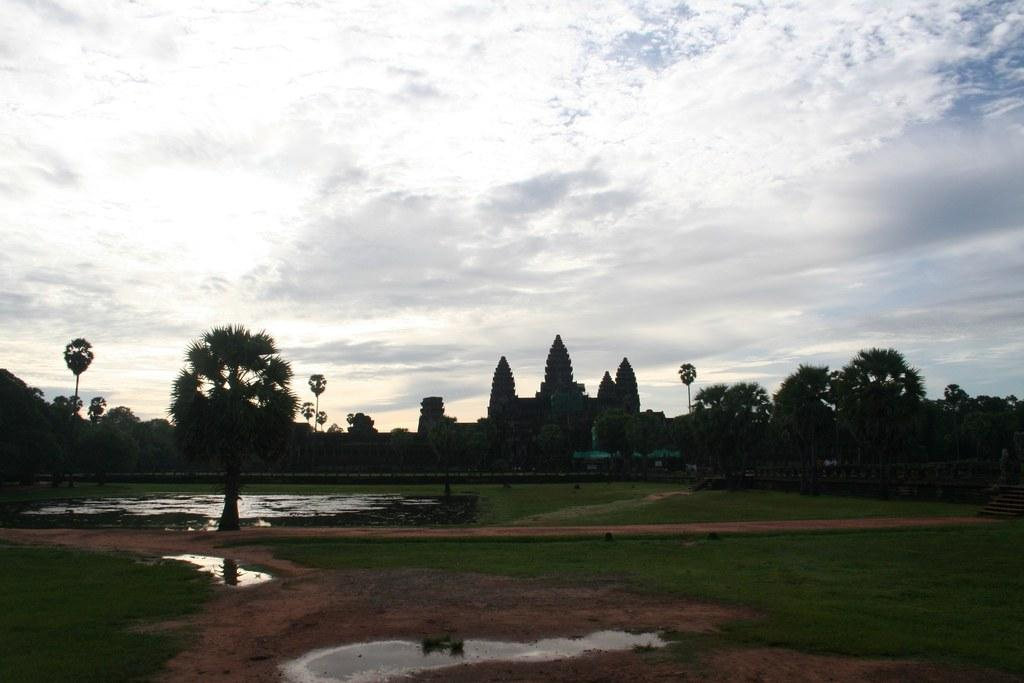What type of scenery is depicted in the image? There is a beautiful scenery in the image. What can be seen growing in the image? Crops are present in the image. What type of vegetation is visible in the image? There are plenty of trees in the image. What is visible in the background of the image? The sky is visible in the background of the image. Can you see a monkey exchanging a camera with a farmer in the image? There is no monkey or camera present in the image, and no exchange is taking place. 